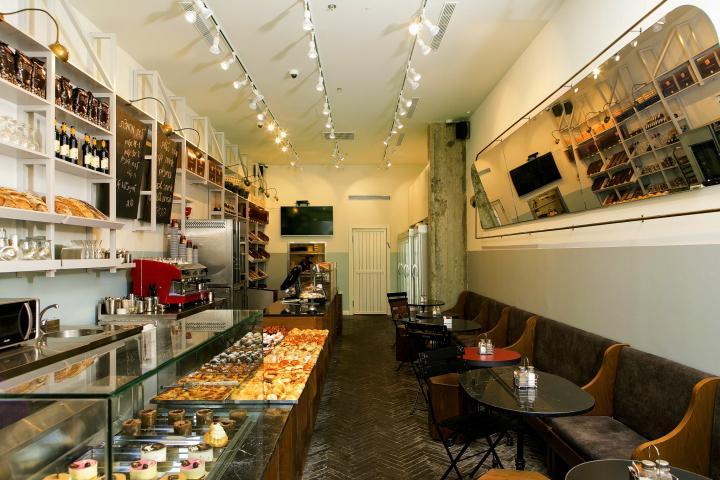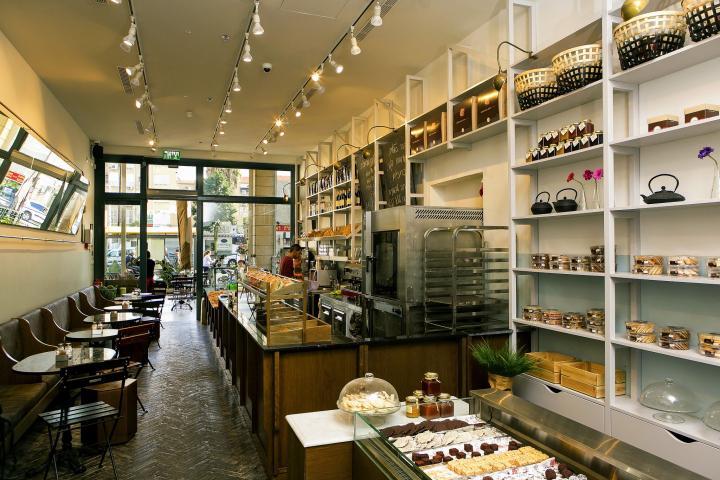The first image is the image on the left, the second image is the image on the right. Considering the images on both sides, is "At least one image shows a bakery interior with rounded tables in front of bench seats along the wall, facing display cases with blackboards hung above them." valid? Answer yes or no. Yes. The first image is the image on the left, the second image is the image on the right. For the images shown, is this caption "In each image, a bakery cafe has its menu posted on one or more black boards, but table seating is seen in only one image." true? Answer yes or no. No. 